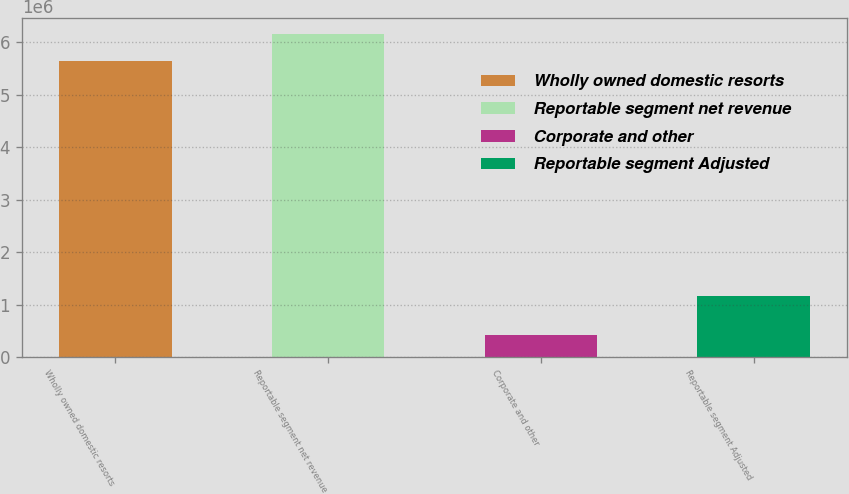Convert chart to OTSL. <chart><loc_0><loc_0><loc_500><loc_500><bar_chart><fcel>Wholly owned domestic resorts<fcel>Reportable segment net revenue<fcel>Corporate and other<fcel>Reportable segment Adjusted<nl><fcel>5.63435e+06<fcel>6.15562e+06<fcel>421651<fcel>1.16541e+06<nl></chart> 